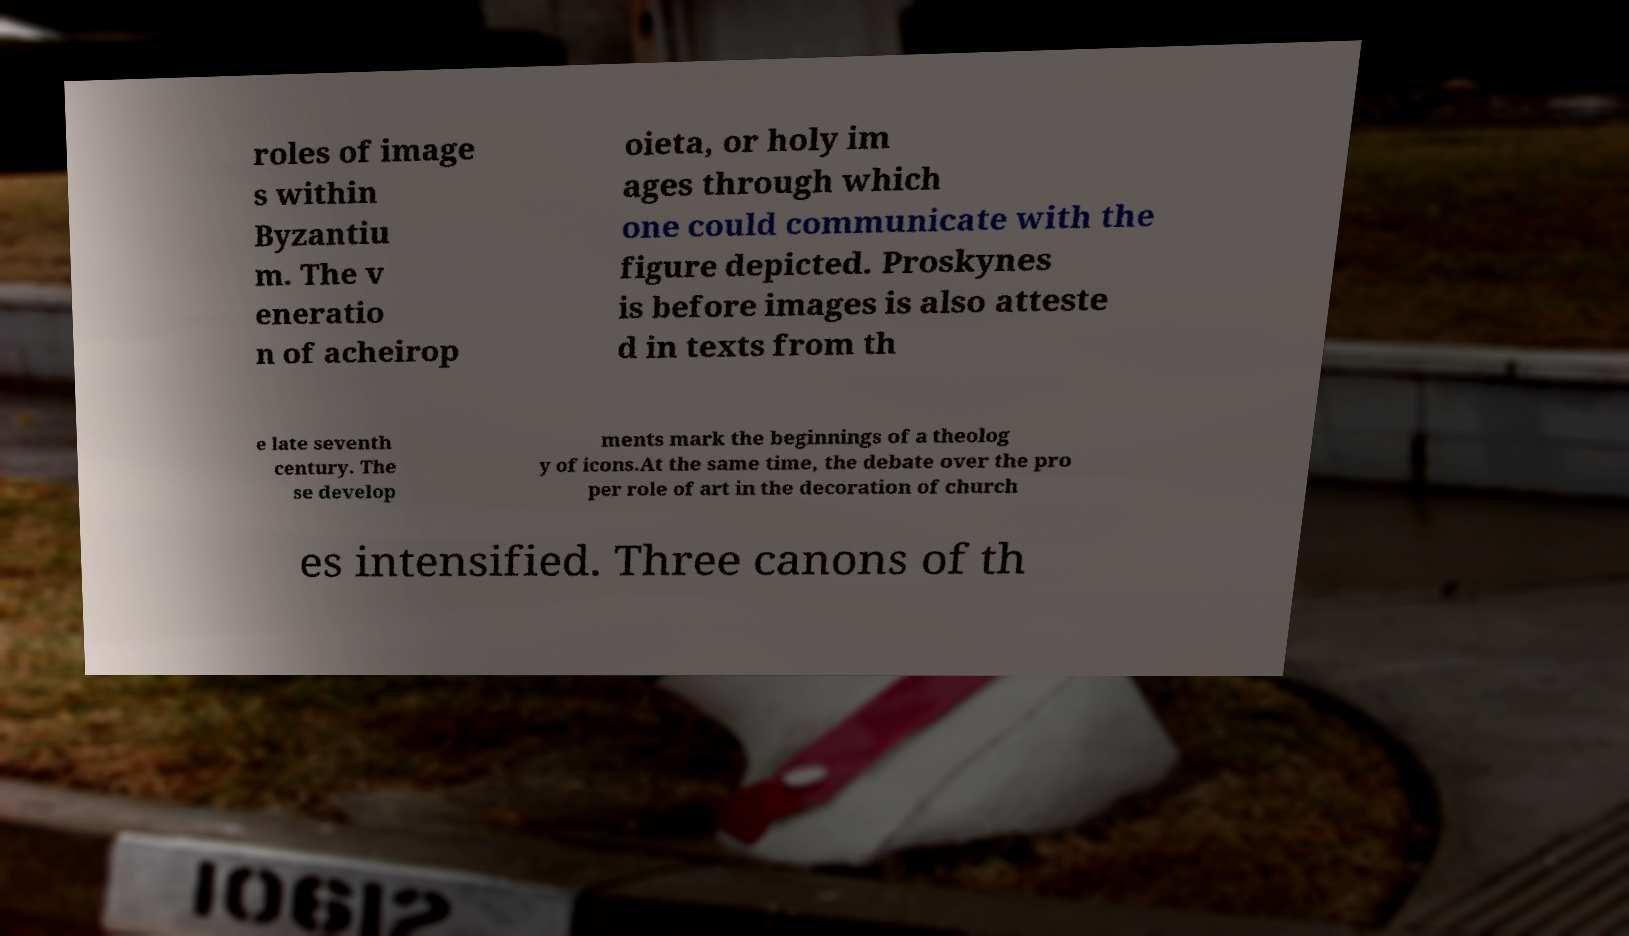I need the written content from this picture converted into text. Can you do that? roles of image s within Byzantiu m. The v eneratio n of acheirop oieta, or holy im ages through which one could communicate with the figure depicted. Proskynes is before images is also atteste d in texts from th e late seventh century. The se develop ments mark the beginnings of a theolog y of icons.At the same time, the debate over the pro per role of art in the decoration of church es intensified. Three canons of th 